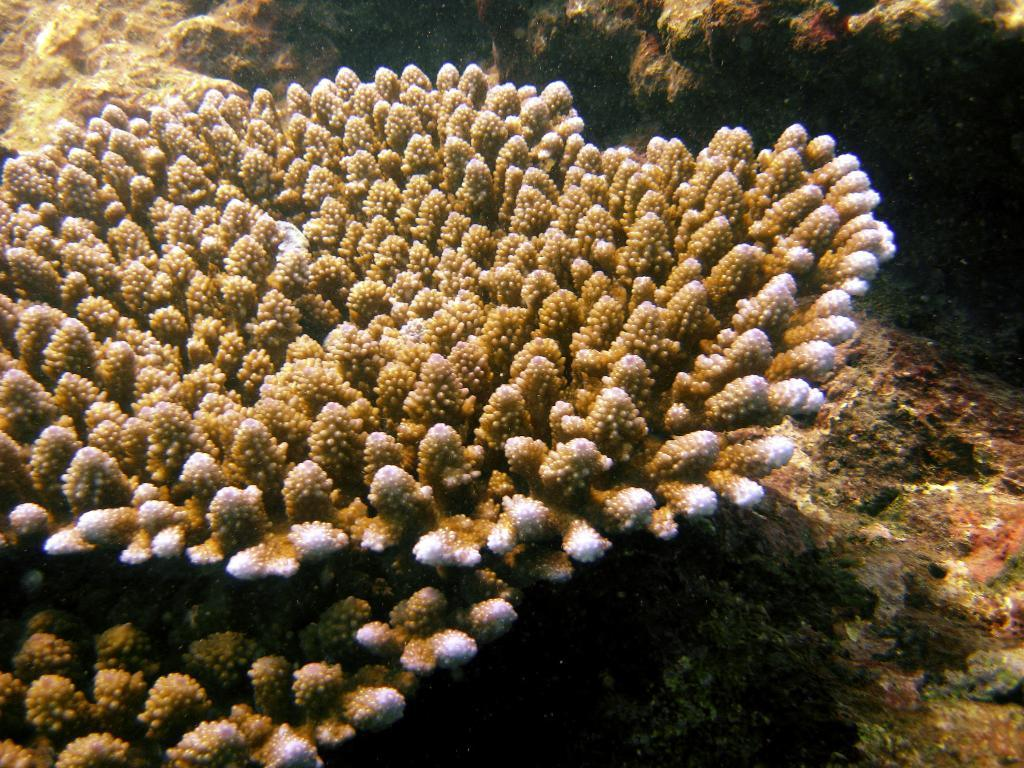Where was the image taken? The image is taken inside water. What can be seen in the background of the image? There are coral reefs in the image. Are there any plants visible in the image? Yes, there are plants in the image. What type of division is taking place in the image? There is no division taking place in the image; it is a photograph of an underwater scene with coral reefs and plants. 